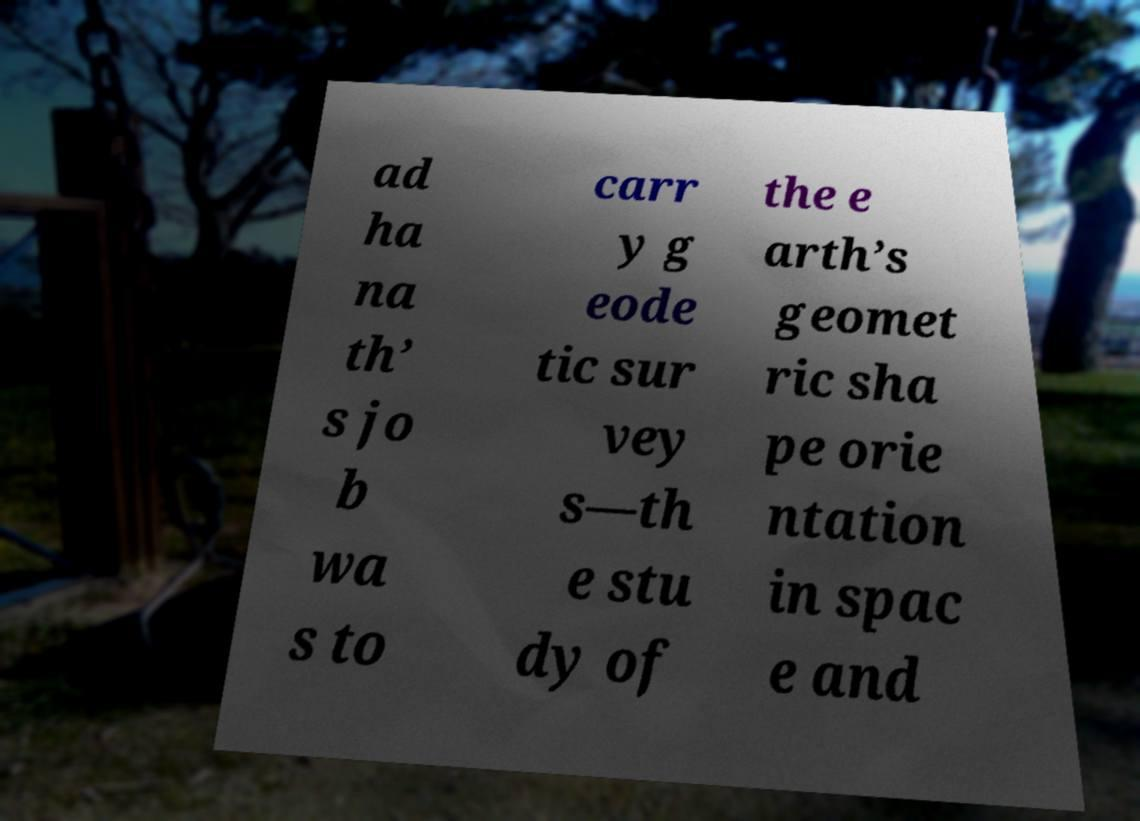For documentation purposes, I need the text within this image transcribed. Could you provide that? ad ha na th’ s jo b wa s to carr y g eode tic sur vey s—th e stu dy of the e arth’s geomet ric sha pe orie ntation in spac e and 